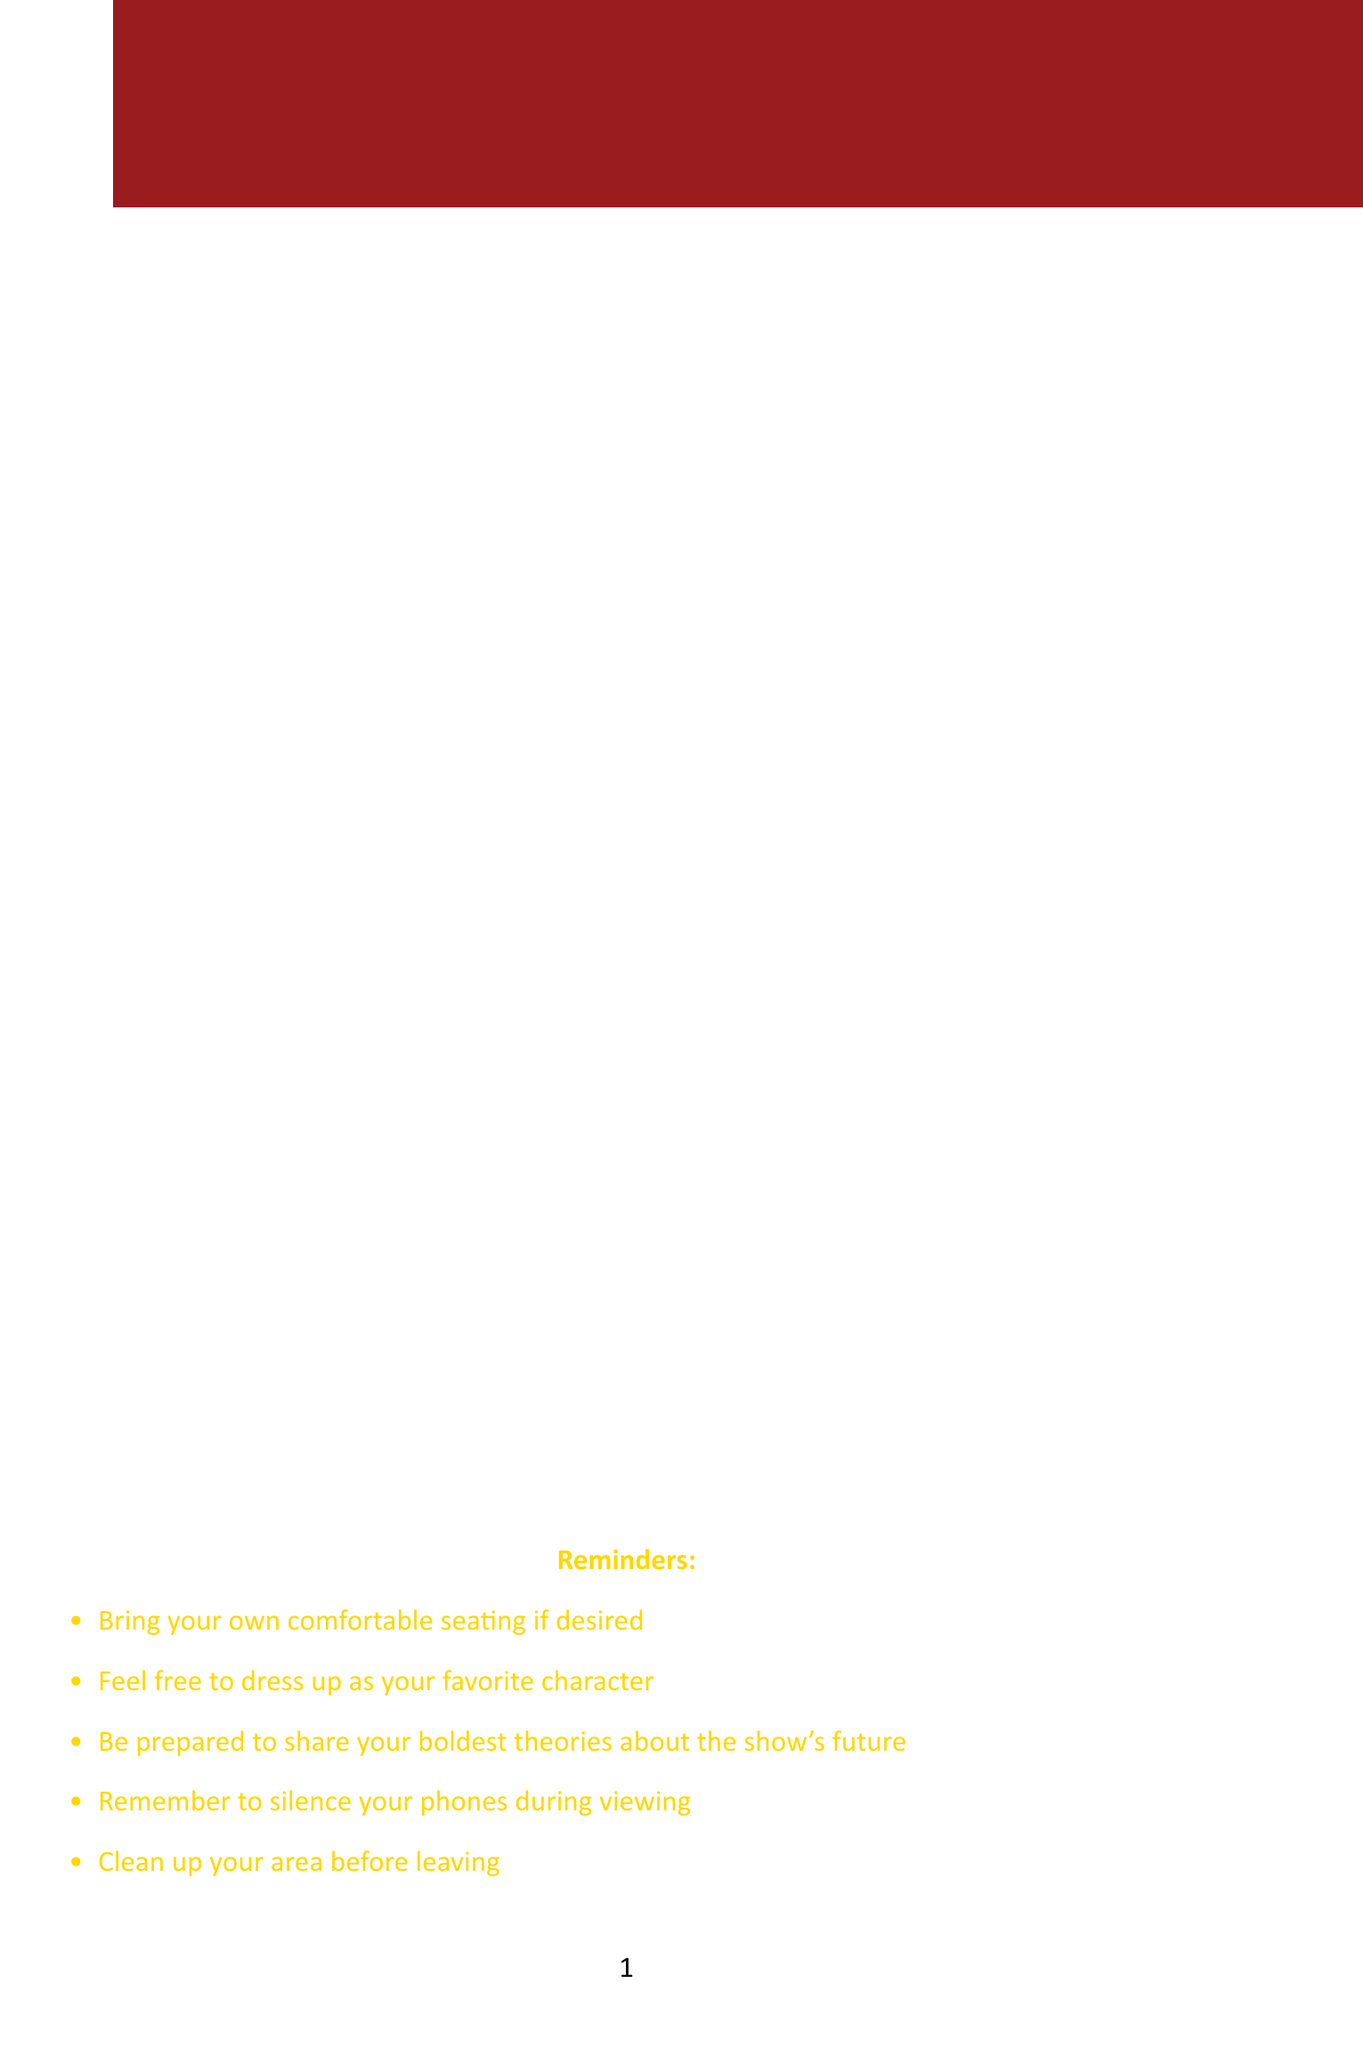what is the date of the viewing party? The date of the viewing party is explicitly stated in the memo as "Friday, June 2, 2023."
Answer: Friday, June 2, 2023 where will the viewing party be held? The location of the viewing party is specified in the document as "Conference Room B."
Answer: Conference Room B who is responsible for the Direwolf Shaped Cookies? The name associated with the Direwolf Shaped Cookies is mentioned in the snack assignments list as "Sarah from Marketing."
Answer: Sarah from Marketing what time does the Episode 1 viewing start? The starting time for Episode 1 viewing is directly indicated in the schedule as "7:00 PM."
Answer: 7:00 PM name one discussion topic planned for the event. The document lists several discussion topics, one of which is "Predictions for House Targaryen's storyline."
Answer: Predictions for House Targaryen's storyline what is the drink being provided by Tom from Finance? Tom from Finance is assigned to bring "King's Landing Punch," as stated in the snack assignments.
Answer: King's Landing Punch how long is the window for discussions after Episode 1? The document states that discussions begin at "8:00 PM," and Episode 2 viewing starts at "8:30 PM," so the window is 30 minutes.
Answer: 30 minutes what is one reminder given in the memo? One of the reminders specified in the memo is to "Bring your own comfortable seating if desired."
Answer: Bring your own comfortable seating if desired who is known as 'The King in the North'? The trivia section directly states that this title refers to "Robb Stark (later Jon Snow)."
Answer: Robb Stark (later Jon Snow) 